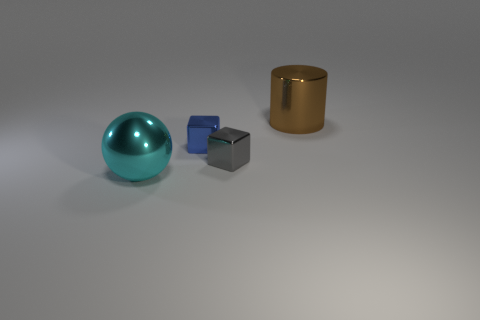Can you describe the lighting and shadows in the scene? The scene has a single prominent light source casting soft shadows to the right of the objects, suggesting the light is coming from the upper left side. The shadows are diffuse, indicating the light is not extremely close to the objects. This lighting results in a gentle contrast, softly illuminating the surfaces and enhancing the texture of the materials. 